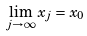<formula> <loc_0><loc_0><loc_500><loc_500>\lim _ { j \rightarrow \infty } x _ { j } = x _ { 0 }</formula> 